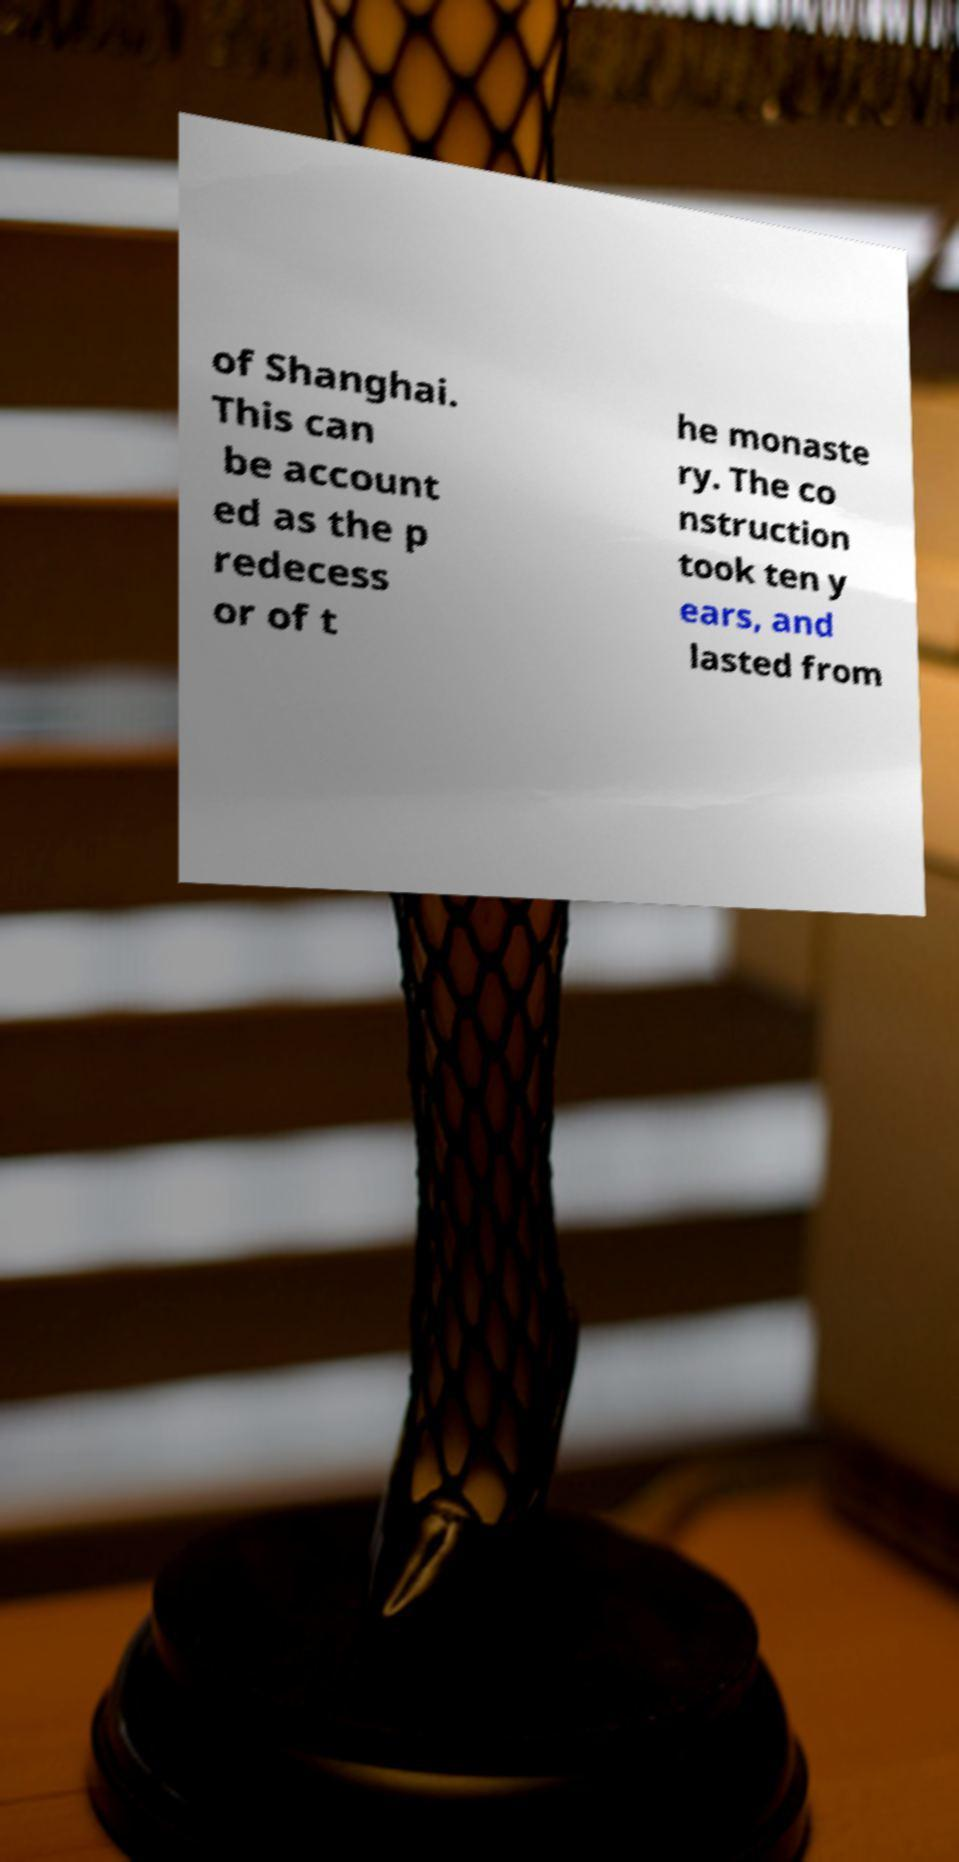Please read and relay the text visible in this image. What does it say? of Shanghai. This can be account ed as the p redecess or of t he monaste ry. The co nstruction took ten y ears, and lasted from 